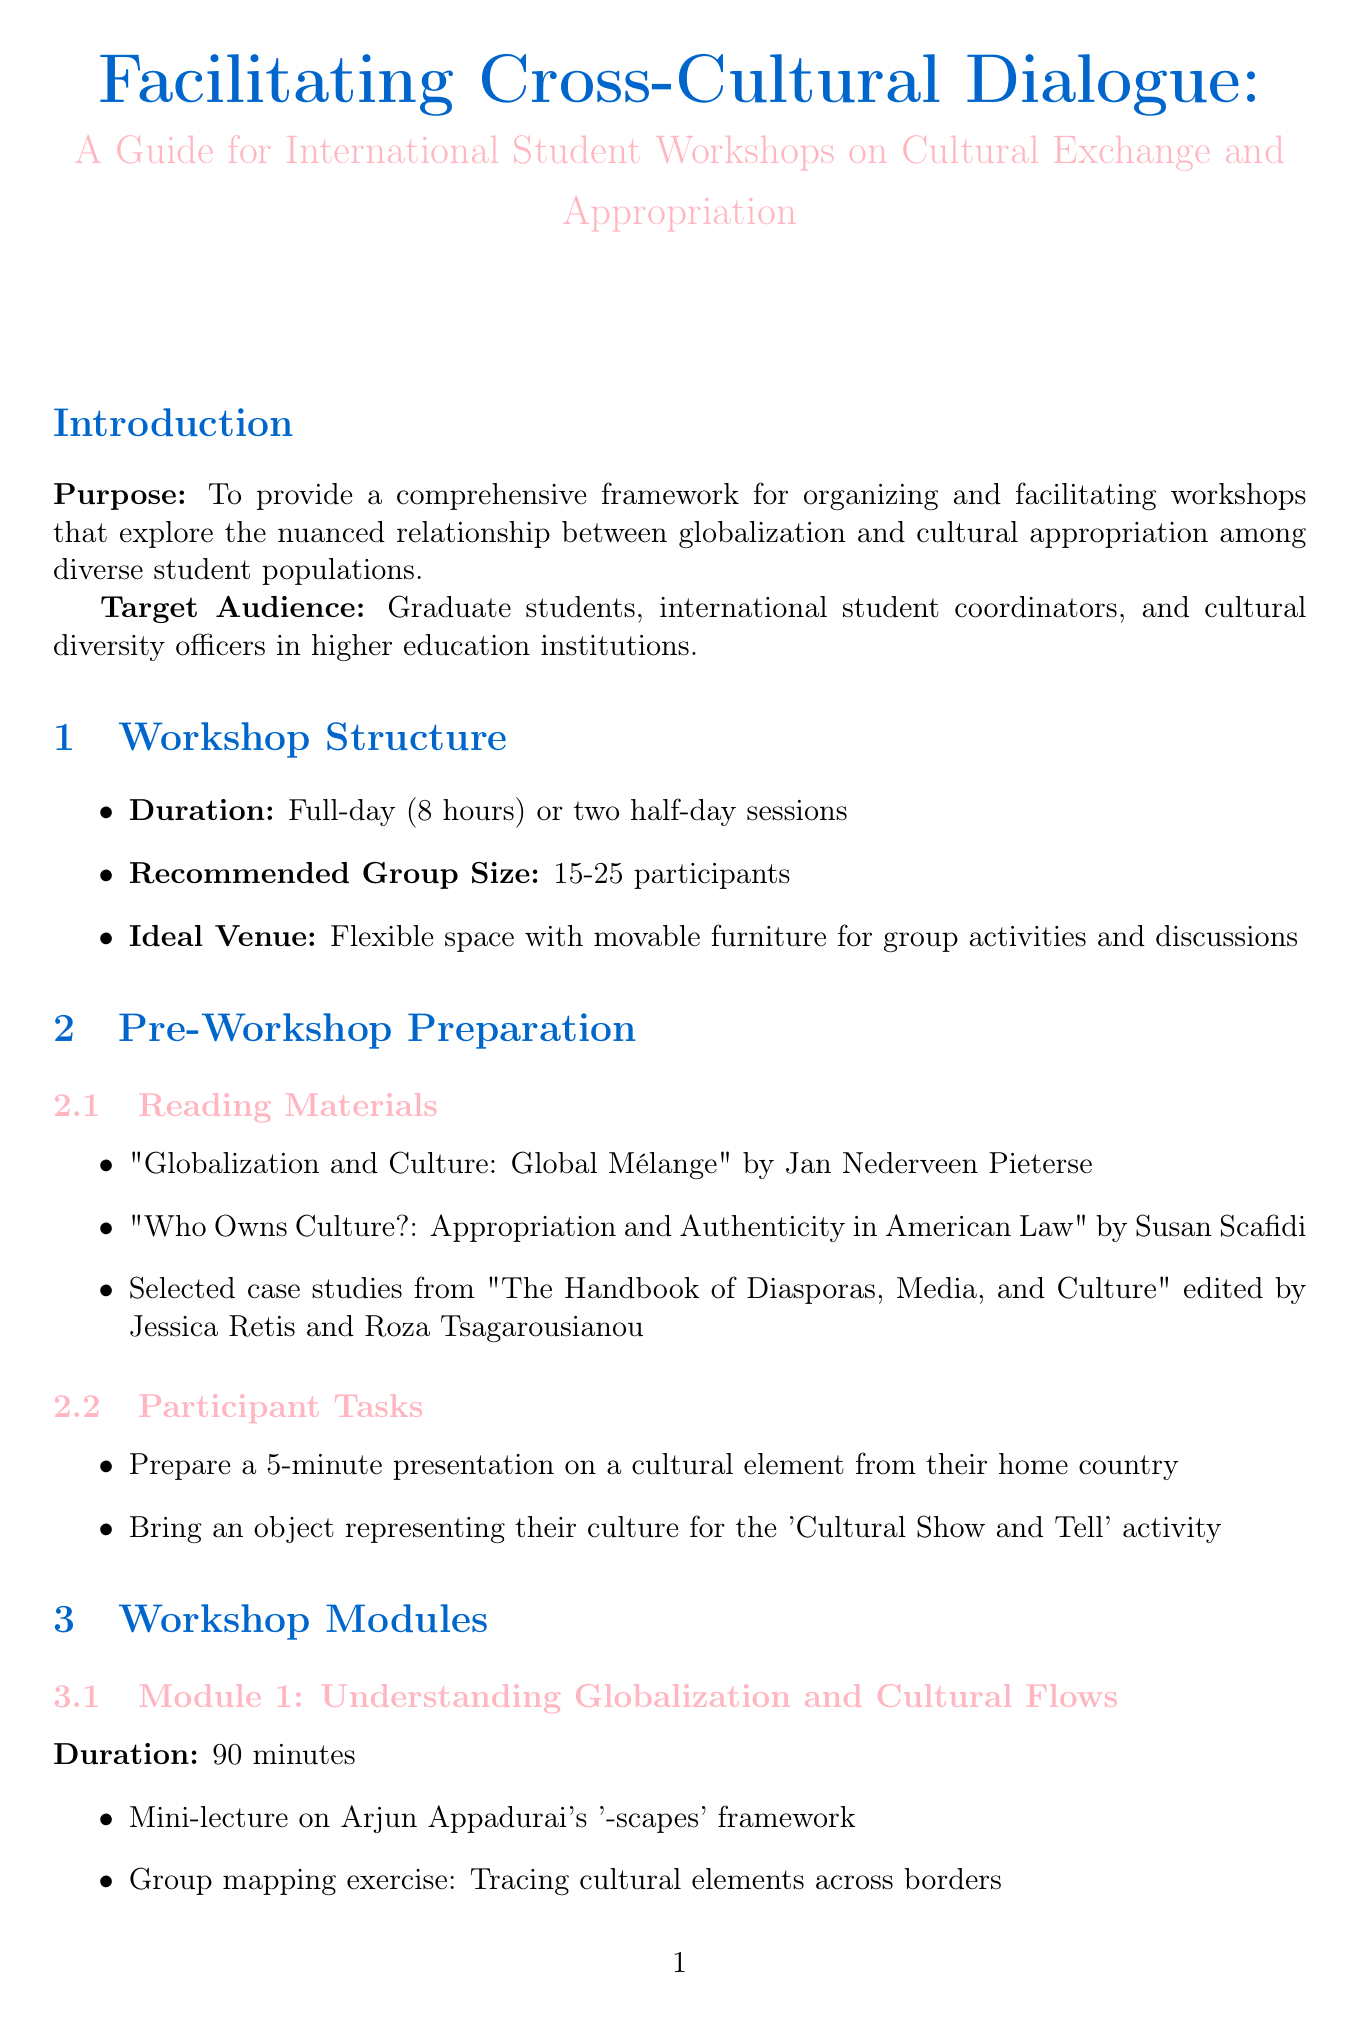What is the title of the manual? The title of the manual is stated in the first section of the document.
Answer: Facilitating Cross-Cultural Dialogue: A Guide for International Student Workshops on Cultural Exchange and Appropriation What is the duration of the workshop? The duration is specified in the workshop structure section.
Answer: Full-day (8 hours) or two half-day sessions What is the recommended group size for the workshops? The recommended group size is mentioned in the workshop structure section.
Answer: 15-25 participants What is one of the reading materials for pre-workshop preparation? One of the reading materials is listed under pre-workshop preparation.
Answer: "Globalization and Culture: Global Mélange" by Jan Nederveen Pieterse What activity is included in Module 2? The activities for each module are detailed in the workshop modules section.
Answer: Debate: "Is cultural appropriation always harmful?" What is a key learning outcome of the workshop? Key learning outcomes are identified in the assessment and feedback section.
Answer: Enhanced understanding of the complexities of cultural exchange in a globalized world What digital platform is recommended for collaborative brainstorming? Recommendations for digital platforms are found in the resources and tools section.
Answer: Padlet for collaborative brainstorming What is one engagement strategy for virtual delivery? Engagement strategies are outlined in the adaptations for virtual delivery section.
Answer: Use of virtual backgrounds to showcase cultural artifacts What is the ideal venue for hosting the workshops? The ideal venue is specified in the workshop structure section.
Answer: Flexible space with movable furniture for group activities and discussions 